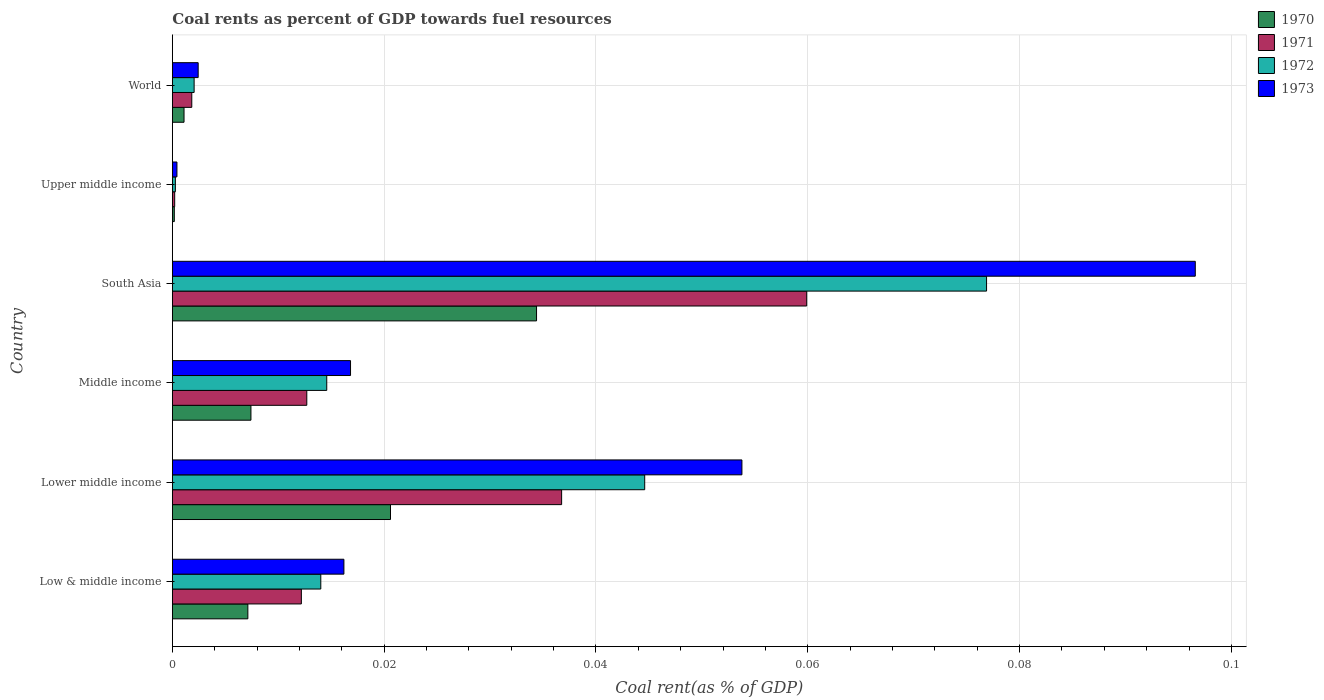Are the number of bars per tick equal to the number of legend labels?
Offer a very short reply. Yes. How many bars are there on the 2nd tick from the top?
Provide a succinct answer. 4. What is the label of the 5th group of bars from the top?
Your response must be concise. Lower middle income. In how many cases, is the number of bars for a given country not equal to the number of legend labels?
Give a very brief answer. 0. What is the coal rent in 1970 in Middle income?
Your answer should be very brief. 0.01. Across all countries, what is the maximum coal rent in 1970?
Provide a short and direct response. 0.03. Across all countries, what is the minimum coal rent in 1971?
Offer a terse response. 0. In which country was the coal rent in 1972 maximum?
Your answer should be very brief. South Asia. In which country was the coal rent in 1970 minimum?
Ensure brevity in your answer.  Upper middle income. What is the total coal rent in 1973 in the graph?
Your response must be concise. 0.19. What is the difference between the coal rent in 1970 in Middle income and that in South Asia?
Give a very brief answer. -0.03. What is the difference between the coal rent in 1970 in Middle income and the coal rent in 1971 in Upper middle income?
Your response must be concise. 0.01. What is the average coal rent in 1971 per country?
Keep it short and to the point. 0.02. What is the difference between the coal rent in 1970 and coal rent in 1972 in World?
Provide a succinct answer. -0. What is the ratio of the coal rent in 1972 in Low & middle income to that in Middle income?
Offer a very short reply. 0.96. Is the coal rent in 1970 in Low & middle income less than that in Lower middle income?
Make the answer very short. Yes. What is the difference between the highest and the second highest coal rent in 1973?
Make the answer very short. 0.04. What is the difference between the highest and the lowest coal rent in 1971?
Offer a very short reply. 0.06. Is it the case that in every country, the sum of the coal rent in 1972 and coal rent in 1971 is greater than the sum of coal rent in 1973 and coal rent in 1970?
Your answer should be compact. No. What does the 1st bar from the top in Low & middle income represents?
Ensure brevity in your answer.  1973. How many bars are there?
Your answer should be very brief. 24. Are all the bars in the graph horizontal?
Offer a very short reply. Yes. What is the difference between two consecutive major ticks on the X-axis?
Ensure brevity in your answer.  0.02. Are the values on the major ticks of X-axis written in scientific E-notation?
Offer a very short reply. No. What is the title of the graph?
Keep it short and to the point. Coal rents as percent of GDP towards fuel resources. What is the label or title of the X-axis?
Your answer should be very brief. Coal rent(as % of GDP). What is the Coal rent(as % of GDP) of 1970 in Low & middle income?
Ensure brevity in your answer.  0.01. What is the Coal rent(as % of GDP) in 1971 in Low & middle income?
Your answer should be compact. 0.01. What is the Coal rent(as % of GDP) in 1972 in Low & middle income?
Keep it short and to the point. 0.01. What is the Coal rent(as % of GDP) of 1973 in Low & middle income?
Make the answer very short. 0.02. What is the Coal rent(as % of GDP) in 1970 in Lower middle income?
Your response must be concise. 0.02. What is the Coal rent(as % of GDP) of 1971 in Lower middle income?
Ensure brevity in your answer.  0.04. What is the Coal rent(as % of GDP) of 1972 in Lower middle income?
Provide a succinct answer. 0.04. What is the Coal rent(as % of GDP) of 1973 in Lower middle income?
Provide a short and direct response. 0.05. What is the Coal rent(as % of GDP) in 1970 in Middle income?
Your answer should be very brief. 0.01. What is the Coal rent(as % of GDP) of 1971 in Middle income?
Give a very brief answer. 0.01. What is the Coal rent(as % of GDP) of 1972 in Middle income?
Offer a very short reply. 0.01. What is the Coal rent(as % of GDP) of 1973 in Middle income?
Keep it short and to the point. 0.02. What is the Coal rent(as % of GDP) in 1970 in South Asia?
Provide a succinct answer. 0.03. What is the Coal rent(as % of GDP) of 1971 in South Asia?
Your answer should be compact. 0.06. What is the Coal rent(as % of GDP) in 1972 in South Asia?
Give a very brief answer. 0.08. What is the Coal rent(as % of GDP) of 1973 in South Asia?
Ensure brevity in your answer.  0.1. What is the Coal rent(as % of GDP) in 1970 in Upper middle income?
Offer a very short reply. 0. What is the Coal rent(as % of GDP) in 1971 in Upper middle income?
Make the answer very short. 0. What is the Coal rent(as % of GDP) of 1972 in Upper middle income?
Offer a terse response. 0. What is the Coal rent(as % of GDP) in 1973 in Upper middle income?
Keep it short and to the point. 0. What is the Coal rent(as % of GDP) in 1970 in World?
Give a very brief answer. 0. What is the Coal rent(as % of GDP) of 1971 in World?
Give a very brief answer. 0. What is the Coal rent(as % of GDP) of 1972 in World?
Offer a very short reply. 0. What is the Coal rent(as % of GDP) in 1973 in World?
Your response must be concise. 0. Across all countries, what is the maximum Coal rent(as % of GDP) of 1970?
Provide a short and direct response. 0.03. Across all countries, what is the maximum Coal rent(as % of GDP) of 1971?
Offer a terse response. 0.06. Across all countries, what is the maximum Coal rent(as % of GDP) in 1972?
Provide a succinct answer. 0.08. Across all countries, what is the maximum Coal rent(as % of GDP) of 1973?
Provide a short and direct response. 0.1. Across all countries, what is the minimum Coal rent(as % of GDP) in 1970?
Provide a short and direct response. 0. Across all countries, what is the minimum Coal rent(as % of GDP) of 1971?
Ensure brevity in your answer.  0. Across all countries, what is the minimum Coal rent(as % of GDP) in 1972?
Keep it short and to the point. 0. Across all countries, what is the minimum Coal rent(as % of GDP) of 1973?
Ensure brevity in your answer.  0. What is the total Coal rent(as % of GDP) in 1970 in the graph?
Your answer should be compact. 0.07. What is the total Coal rent(as % of GDP) in 1971 in the graph?
Provide a short and direct response. 0.12. What is the total Coal rent(as % of GDP) in 1972 in the graph?
Provide a succinct answer. 0.15. What is the total Coal rent(as % of GDP) of 1973 in the graph?
Offer a very short reply. 0.19. What is the difference between the Coal rent(as % of GDP) in 1970 in Low & middle income and that in Lower middle income?
Keep it short and to the point. -0.01. What is the difference between the Coal rent(as % of GDP) in 1971 in Low & middle income and that in Lower middle income?
Your response must be concise. -0.02. What is the difference between the Coal rent(as % of GDP) in 1972 in Low & middle income and that in Lower middle income?
Provide a succinct answer. -0.03. What is the difference between the Coal rent(as % of GDP) of 1973 in Low & middle income and that in Lower middle income?
Your answer should be very brief. -0.04. What is the difference between the Coal rent(as % of GDP) of 1970 in Low & middle income and that in Middle income?
Make the answer very short. -0. What is the difference between the Coal rent(as % of GDP) in 1971 in Low & middle income and that in Middle income?
Provide a short and direct response. -0. What is the difference between the Coal rent(as % of GDP) of 1972 in Low & middle income and that in Middle income?
Make the answer very short. -0. What is the difference between the Coal rent(as % of GDP) of 1973 in Low & middle income and that in Middle income?
Ensure brevity in your answer.  -0. What is the difference between the Coal rent(as % of GDP) of 1970 in Low & middle income and that in South Asia?
Your answer should be compact. -0.03. What is the difference between the Coal rent(as % of GDP) in 1971 in Low & middle income and that in South Asia?
Your answer should be very brief. -0.05. What is the difference between the Coal rent(as % of GDP) of 1972 in Low & middle income and that in South Asia?
Keep it short and to the point. -0.06. What is the difference between the Coal rent(as % of GDP) in 1973 in Low & middle income and that in South Asia?
Make the answer very short. -0.08. What is the difference between the Coal rent(as % of GDP) in 1970 in Low & middle income and that in Upper middle income?
Make the answer very short. 0.01. What is the difference between the Coal rent(as % of GDP) of 1971 in Low & middle income and that in Upper middle income?
Make the answer very short. 0.01. What is the difference between the Coal rent(as % of GDP) of 1972 in Low & middle income and that in Upper middle income?
Provide a succinct answer. 0.01. What is the difference between the Coal rent(as % of GDP) of 1973 in Low & middle income and that in Upper middle income?
Offer a very short reply. 0.02. What is the difference between the Coal rent(as % of GDP) in 1970 in Low & middle income and that in World?
Your answer should be very brief. 0.01. What is the difference between the Coal rent(as % of GDP) in 1971 in Low & middle income and that in World?
Provide a succinct answer. 0.01. What is the difference between the Coal rent(as % of GDP) of 1972 in Low & middle income and that in World?
Keep it short and to the point. 0.01. What is the difference between the Coal rent(as % of GDP) of 1973 in Low & middle income and that in World?
Give a very brief answer. 0.01. What is the difference between the Coal rent(as % of GDP) of 1970 in Lower middle income and that in Middle income?
Your answer should be compact. 0.01. What is the difference between the Coal rent(as % of GDP) of 1971 in Lower middle income and that in Middle income?
Offer a terse response. 0.02. What is the difference between the Coal rent(as % of GDP) in 1972 in Lower middle income and that in Middle income?
Offer a very short reply. 0.03. What is the difference between the Coal rent(as % of GDP) of 1973 in Lower middle income and that in Middle income?
Provide a short and direct response. 0.04. What is the difference between the Coal rent(as % of GDP) in 1970 in Lower middle income and that in South Asia?
Provide a succinct answer. -0.01. What is the difference between the Coal rent(as % of GDP) of 1971 in Lower middle income and that in South Asia?
Offer a very short reply. -0.02. What is the difference between the Coal rent(as % of GDP) of 1972 in Lower middle income and that in South Asia?
Your response must be concise. -0.03. What is the difference between the Coal rent(as % of GDP) in 1973 in Lower middle income and that in South Asia?
Your answer should be compact. -0.04. What is the difference between the Coal rent(as % of GDP) in 1970 in Lower middle income and that in Upper middle income?
Keep it short and to the point. 0.02. What is the difference between the Coal rent(as % of GDP) in 1971 in Lower middle income and that in Upper middle income?
Keep it short and to the point. 0.04. What is the difference between the Coal rent(as % of GDP) in 1972 in Lower middle income and that in Upper middle income?
Offer a very short reply. 0.04. What is the difference between the Coal rent(as % of GDP) in 1973 in Lower middle income and that in Upper middle income?
Provide a short and direct response. 0.05. What is the difference between the Coal rent(as % of GDP) in 1970 in Lower middle income and that in World?
Give a very brief answer. 0.02. What is the difference between the Coal rent(as % of GDP) in 1971 in Lower middle income and that in World?
Give a very brief answer. 0.03. What is the difference between the Coal rent(as % of GDP) in 1972 in Lower middle income and that in World?
Offer a very short reply. 0.04. What is the difference between the Coal rent(as % of GDP) of 1973 in Lower middle income and that in World?
Your response must be concise. 0.05. What is the difference between the Coal rent(as % of GDP) in 1970 in Middle income and that in South Asia?
Make the answer very short. -0.03. What is the difference between the Coal rent(as % of GDP) of 1971 in Middle income and that in South Asia?
Offer a very short reply. -0.05. What is the difference between the Coal rent(as % of GDP) of 1972 in Middle income and that in South Asia?
Keep it short and to the point. -0.06. What is the difference between the Coal rent(as % of GDP) in 1973 in Middle income and that in South Asia?
Offer a very short reply. -0.08. What is the difference between the Coal rent(as % of GDP) of 1970 in Middle income and that in Upper middle income?
Your answer should be compact. 0.01. What is the difference between the Coal rent(as % of GDP) in 1971 in Middle income and that in Upper middle income?
Ensure brevity in your answer.  0.01. What is the difference between the Coal rent(as % of GDP) in 1972 in Middle income and that in Upper middle income?
Offer a terse response. 0.01. What is the difference between the Coal rent(as % of GDP) of 1973 in Middle income and that in Upper middle income?
Keep it short and to the point. 0.02. What is the difference between the Coal rent(as % of GDP) of 1970 in Middle income and that in World?
Keep it short and to the point. 0.01. What is the difference between the Coal rent(as % of GDP) in 1971 in Middle income and that in World?
Offer a terse response. 0.01. What is the difference between the Coal rent(as % of GDP) in 1972 in Middle income and that in World?
Provide a succinct answer. 0.01. What is the difference between the Coal rent(as % of GDP) in 1973 in Middle income and that in World?
Offer a terse response. 0.01. What is the difference between the Coal rent(as % of GDP) of 1970 in South Asia and that in Upper middle income?
Your response must be concise. 0.03. What is the difference between the Coal rent(as % of GDP) of 1971 in South Asia and that in Upper middle income?
Your response must be concise. 0.06. What is the difference between the Coal rent(as % of GDP) in 1972 in South Asia and that in Upper middle income?
Your response must be concise. 0.08. What is the difference between the Coal rent(as % of GDP) of 1973 in South Asia and that in Upper middle income?
Provide a short and direct response. 0.1. What is the difference between the Coal rent(as % of GDP) of 1970 in South Asia and that in World?
Ensure brevity in your answer.  0.03. What is the difference between the Coal rent(as % of GDP) of 1971 in South Asia and that in World?
Ensure brevity in your answer.  0.06. What is the difference between the Coal rent(as % of GDP) in 1972 in South Asia and that in World?
Your answer should be very brief. 0.07. What is the difference between the Coal rent(as % of GDP) of 1973 in South Asia and that in World?
Provide a succinct answer. 0.09. What is the difference between the Coal rent(as % of GDP) of 1970 in Upper middle income and that in World?
Offer a terse response. -0. What is the difference between the Coal rent(as % of GDP) in 1971 in Upper middle income and that in World?
Provide a succinct answer. -0. What is the difference between the Coal rent(as % of GDP) of 1972 in Upper middle income and that in World?
Your answer should be very brief. -0. What is the difference between the Coal rent(as % of GDP) of 1973 in Upper middle income and that in World?
Provide a short and direct response. -0. What is the difference between the Coal rent(as % of GDP) of 1970 in Low & middle income and the Coal rent(as % of GDP) of 1971 in Lower middle income?
Provide a short and direct response. -0.03. What is the difference between the Coal rent(as % of GDP) of 1970 in Low & middle income and the Coal rent(as % of GDP) of 1972 in Lower middle income?
Offer a terse response. -0.04. What is the difference between the Coal rent(as % of GDP) of 1970 in Low & middle income and the Coal rent(as % of GDP) of 1973 in Lower middle income?
Keep it short and to the point. -0.05. What is the difference between the Coal rent(as % of GDP) of 1971 in Low & middle income and the Coal rent(as % of GDP) of 1972 in Lower middle income?
Offer a terse response. -0.03. What is the difference between the Coal rent(as % of GDP) of 1971 in Low & middle income and the Coal rent(as % of GDP) of 1973 in Lower middle income?
Your response must be concise. -0.04. What is the difference between the Coal rent(as % of GDP) of 1972 in Low & middle income and the Coal rent(as % of GDP) of 1973 in Lower middle income?
Your answer should be very brief. -0.04. What is the difference between the Coal rent(as % of GDP) of 1970 in Low & middle income and the Coal rent(as % of GDP) of 1971 in Middle income?
Provide a succinct answer. -0.01. What is the difference between the Coal rent(as % of GDP) in 1970 in Low & middle income and the Coal rent(as % of GDP) in 1972 in Middle income?
Offer a terse response. -0.01. What is the difference between the Coal rent(as % of GDP) in 1970 in Low & middle income and the Coal rent(as % of GDP) in 1973 in Middle income?
Give a very brief answer. -0.01. What is the difference between the Coal rent(as % of GDP) in 1971 in Low & middle income and the Coal rent(as % of GDP) in 1972 in Middle income?
Make the answer very short. -0. What is the difference between the Coal rent(as % of GDP) in 1971 in Low & middle income and the Coal rent(as % of GDP) in 1973 in Middle income?
Offer a very short reply. -0. What is the difference between the Coal rent(as % of GDP) of 1972 in Low & middle income and the Coal rent(as % of GDP) of 1973 in Middle income?
Your answer should be compact. -0. What is the difference between the Coal rent(as % of GDP) of 1970 in Low & middle income and the Coal rent(as % of GDP) of 1971 in South Asia?
Ensure brevity in your answer.  -0.05. What is the difference between the Coal rent(as % of GDP) of 1970 in Low & middle income and the Coal rent(as % of GDP) of 1972 in South Asia?
Give a very brief answer. -0.07. What is the difference between the Coal rent(as % of GDP) of 1970 in Low & middle income and the Coal rent(as % of GDP) of 1973 in South Asia?
Ensure brevity in your answer.  -0.09. What is the difference between the Coal rent(as % of GDP) of 1971 in Low & middle income and the Coal rent(as % of GDP) of 1972 in South Asia?
Provide a succinct answer. -0.06. What is the difference between the Coal rent(as % of GDP) of 1971 in Low & middle income and the Coal rent(as % of GDP) of 1973 in South Asia?
Offer a very short reply. -0.08. What is the difference between the Coal rent(as % of GDP) in 1972 in Low & middle income and the Coal rent(as % of GDP) in 1973 in South Asia?
Keep it short and to the point. -0.08. What is the difference between the Coal rent(as % of GDP) of 1970 in Low & middle income and the Coal rent(as % of GDP) of 1971 in Upper middle income?
Ensure brevity in your answer.  0.01. What is the difference between the Coal rent(as % of GDP) of 1970 in Low & middle income and the Coal rent(as % of GDP) of 1972 in Upper middle income?
Your answer should be compact. 0.01. What is the difference between the Coal rent(as % of GDP) in 1970 in Low & middle income and the Coal rent(as % of GDP) in 1973 in Upper middle income?
Make the answer very short. 0.01. What is the difference between the Coal rent(as % of GDP) in 1971 in Low & middle income and the Coal rent(as % of GDP) in 1972 in Upper middle income?
Give a very brief answer. 0.01. What is the difference between the Coal rent(as % of GDP) in 1971 in Low & middle income and the Coal rent(as % of GDP) in 1973 in Upper middle income?
Offer a very short reply. 0.01. What is the difference between the Coal rent(as % of GDP) of 1972 in Low & middle income and the Coal rent(as % of GDP) of 1973 in Upper middle income?
Your answer should be very brief. 0.01. What is the difference between the Coal rent(as % of GDP) in 1970 in Low & middle income and the Coal rent(as % of GDP) in 1971 in World?
Keep it short and to the point. 0.01. What is the difference between the Coal rent(as % of GDP) of 1970 in Low & middle income and the Coal rent(as % of GDP) of 1972 in World?
Make the answer very short. 0.01. What is the difference between the Coal rent(as % of GDP) in 1970 in Low & middle income and the Coal rent(as % of GDP) in 1973 in World?
Make the answer very short. 0. What is the difference between the Coal rent(as % of GDP) of 1971 in Low & middle income and the Coal rent(as % of GDP) of 1972 in World?
Provide a short and direct response. 0.01. What is the difference between the Coal rent(as % of GDP) of 1971 in Low & middle income and the Coal rent(as % of GDP) of 1973 in World?
Your response must be concise. 0.01. What is the difference between the Coal rent(as % of GDP) of 1972 in Low & middle income and the Coal rent(as % of GDP) of 1973 in World?
Keep it short and to the point. 0.01. What is the difference between the Coal rent(as % of GDP) of 1970 in Lower middle income and the Coal rent(as % of GDP) of 1971 in Middle income?
Your answer should be very brief. 0.01. What is the difference between the Coal rent(as % of GDP) in 1970 in Lower middle income and the Coal rent(as % of GDP) in 1972 in Middle income?
Your answer should be very brief. 0.01. What is the difference between the Coal rent(as % of GDP) in 1970 in Lower middle income and the Coal rent(as % of GDP) in 1973 in Middle income?
Give a very brief answer. 0. What is the difference between the Coal rent(as % of GDP) in 1971 in Lower middle income and the Coal rent(as % of GDP) in 1972 in Middle income?
Offer a very short reply. 0.02. What is the difference between the Coal rent(as % of GDP) in 1971 in Lower middle income and the Coal rent(as % of GDP) in 1973 in Middle income?
Your response must be concise. 0.02. What is the difference between the Coal rent(as % of GDP) of 1972 in Lower middle income and the Coal rent(as % of GDP) of 1973 in Middle income?
Offer a very short reply. 0.03. What is the difference between the Coal rent(as % of GDP) in 1970 in Lower middle income and the Coal rent(as % of GDP) in 1971 in South Asia?
Your answer should be compact. -0.04. What is the difference between the Coal rent(as % of GDP) in 1970 in Lower middle income and the Coal rent(as % of GDP) in 1972 in South Asia?
Provide a succinct answer. -0.06. What is the difference between the Coal rent(as % of GDP) of 1970 in Lower middle income and the Coal rent(as % of GDP) of 1973 in South Asia?
Your answer should be very brief. -0.08. What is the difference between the Coal rent(as % of GDP) in 1971 in Lower middle income and the Coal rent(as % of GDP) in 1972 in South Asia?
Keep it short and to the point. -0.04. What is the difference between the Coal rent(as % of GDP) in 1971 in Lower middle income and the Coal rent(as % of GDP) in 1973 in South Asia?
Your answer should be very brief. -0.06. What is the difference between the Coal rent(as % of GDP) of 1972 in Lower middle income and the Coal rent(as % of GDP) of 1973 in South Asia?
Your response must be concise. -0.05. What is the difference between the Coal rent(as % of GDP) of 1970 in Lower middle income and the Coal rent(as % of GDP) of 1971 in Upper middle income?
Your answer should be compact. 0.02. What is the difference between the Coal rent(as % of GDP) in 1970 in Lower middle income and the Coal rent(as % of GDP) in 1972 in Upper middle income?
Your answer should be very brief. 0.02. What is the difference between the Coal rent(as % of GDP) of 1970 in Lower middle income and the Coal rent(as % of GDP) of 1973 in Upper middle income?
Provide a short and direct response. 0.02. What is the difference between the Coal rent(as % of GDP) in 1971 in Lower middle income and the Coal rent(as % of GDP) in 1972 in Upper middle income?
Offer a very short reply. 0.04. What is the difference between the Coal rent(as % of GDP) in 1971 in Lower middle income and the Coal rent(as % of GDP) in 1973 in Upper middle income?
Offer a very short reply. 0.04. What is the difference between the Coal rent(as % of GDP) in 1972 in Lower middle income and the Coal rent(as % of GDP) in 1973 in Upper middle income?
Your answer should be very brief. 0.04. What is the difference between the Coal rent(as % of GDP) of 1970 in Lower middle income and the Coal rent(as % of GDP) of 1971 in World?
Offer a very short reply. 0.02. What is the difference between the Coal rent(as % of GDP) in 1970 in Lower middle income and the Coal rent(as % of GDP) in 1972 in World?
Provide a succinct answer. 0.02. What is the difference between the Coal rent(as % of GDP) in 1970 in Lower middle income and the Coal rent(as % of GDP) in 1973 in World?
Your response must be concise. 0.02. What is the difference between the Coal rent(as % of GDP) in 1971 in Lower middle income and the Coal rent(as % of GDP) in 1972 in World?
Your answer should be compact. 0.03. What is the difference between the Coal rent(as % of GDP) of 1971 in Lower middle income and the Coal rent(as % of GDP) of 1973 in World?
Offer a very short reply. 0.03. What is the difference between the Coal rent(as % of GDP) of 1972 in Lower middle income and the Coal rent(as % of GDP) of 1973 in World?
Provide a succinct answer. 0.04. What is the difference between the Coal rent(as % of GDP) of 1970 in Middle income and the Coal rent(as % of GDP) of 1971 in South Asia?
Make the answer very short. -0.05. What is the difference between the Coal rent(as % of GDP) of 1970 in Middle income and the Coal rent(as % of GDP) of 1972 in South Asia?
Ensure brevity in your answer.  -0.07. What is the difference between the Coal rent(as % of GDP) of 1970 in Middle income and the Coal rent(as % of GDP) of 1973 in South Asia?
Keep it short and to the point. -0.09. What is the difference between the Coal rent(as % of GDP) in 1971 in Middle income and the Coal rent(as % of GDP) in 1972 in South Asia?
Give a very brief answer. -0.06. What is the difference between the Coal rent(as % of GDP) of 1971 in Middle income and the Coal rent(as % of GDP) of 1973 in South Asia?
Your answer should be compact. -0.08. What is the difference between the Coal rent(as % of GDP) in 1972 in Middle income and the Coal rent(as % of GDP) in 1973 in South Asia?
Give a very brief answer. -0.08. What is the difference between the Coal rent(as % of GDP) in 1970 in Middle income and the Coal rent(as % of GDP) in 1971 in Upper middle income?
Offer a terse response. 0.01. What is the difference between the Coal rent(as % of GDP) of 1970 in Middle income and the Coal rent(as % of GDP) of 1972 in Upper middle income?
Offer a very short reply. 0.01. What is the difference between the Coal rent(as % of GDP) in 1970 in Middle income and the Coal rent(as % of GDP) in 1973 in Upper middle income?
Your answer should be very brief. 0.01. What is the difference between the Coal rent(as % of GDP) in 1971 in Middle income and the Coal rent(as % of GDP) in 1972 in Upper middle income?
Your answer should be very brief. 0.01. What is the difference between the Coal rent(as % of GDP) of 1971 in Middle income and the Coal rent(as % of GDP) of 1973 in Upper middle income?
Ensure brevity in your answer.  0.01. What is the difference between the Coal rent(as % of GDP) of 1972 in Middle income and the Coal rent(as % of GDP) of 1973 in Upper middle income?
Your answer should be very brief. 0.01. What is the difference between the Coal rent(as % of GDP) in 1970 in Middle income and the Coal rent(as % of GDP) in 1971 in World?
Provide a short and direct response. 0.01. What is the difference between the Coal rent(as % of GDP) in 1970 in Middle income and the Coal rent(as % of GDP) in 1972 in World?
Your response must be concise. 0.01. What is the difference between the Coal rent(as % of GDP) of 1970 in Middle income and the Coal rent(as % of GDP) of 1973 in World?
Your response must be concise. 0.01. What is the difference between the Coal rent(as % of GDP) of 1971 in Middle income and the Coal rent(as % of GDP) of 1972 in World?
Your response must be concise. 0.01. What is the difference between the Coal rent(as % of GDP) of 1971 in Middle income and the Coal rent(as % of GDP) of 1973 in World?
Offer a terse response. 0.01. What is the difference between the Coal rent(as % of GDP) of 1972 in Middle income and the Coal rent(as % of GDP) of 1973 in World?
Keep it short and to the point. 0.01. What is the difference between the Coal rent(as % of GDP) in 1970 in South Asia and the Coal rent(as % of GDP) in 1971 in Upper middle income?
Offer a terse response. 0.03. What is the difference between the Coal rent(as % of GDP) of 1970 in South Asia and the Coal rent(as % of GDP) of 1972 in Upper middle income?
Make the answer very short. 0.03. What is the difference between the Coal rent(as % of GDP) in 1970 in South Asia and the Coal rent(as % of GDP) in 1973 in Upper middle income?
Offer a very short reply. 0.03. What is the difference between the Coal rent(as % of GDP) in 1971 in South Asia and the Coal rent(as % of GDP) in 1972 in Upper middle income?
Make the answer very short. 0.06. What is the difference between the Coal rent(as % of GDP) in 1971 in South Asia and the Coal rent(as % of GDP) in 1973 in Upper middle income?
Provide a short and direct response. 0.06. What is the difference between the Coal rent(as % of GDP) of 1972 in South Asia and the Coal rent(as % of GDP) of 1973 in Upper middle income?
Offer a very short reply. 0.08. What is the difference between the Coal rent(as % of GDP) of 1970 in South Asia and the Coal rent(as % of GDP) of 1971 in World?
Make the answer very short. 0.03. What is the difference between the Coal rent(as % of GDP) in 1970 in South Asia and the Coal rent(as % of GDP) in 1972 in World?
Make the answer very short. 0.03. What is the difference between the Coal rent(as % of GDP) of 1970 in South Asia and the Coal rent(as % of GDP) of 1973 in World?
Your response must be concise. 0.03. What is the difference between the Coal rent(as % of GDP) of 1971 in South Asia and the Coal rent(as % of GDP) of 1972 in World?
Provide a succinct answer. 0.06. What is the difference between the Coal rent(as % of GDP) of 1971 in South Asia and the Coal rent(as % of GDP) of 1973 in World?
Offer a terse response. 0.06. What is the difference between the Coal rent(as % of GDP) of 1972 in South Asia and the Coal rent(as % of GDP) of 1973 in World?
Make the answer very short. 0.07. What is the difference between the Coal rent(as % of GDP) in 1970 in Upper middle income and the Coal rent(as % of GDP) in 1971 in World?
Offer a terse response. -0. What is the difference between the Coal rent(as % of GDP) of 1970 in Upper middle income and the Coal rent(as % of GDP) of 1972 in World?
Offer a terse response. -0. What is the difference between the Coal rent(as % of GDP) in 1970 in Upper middle income and the Coal rent(as % of GDP) in 1973 in World?
Keep it short and to the point. -0. What is the difference between the Coal rent(as % of GDP) in 1971 in Upper middle income and the Coal rent(as % of GDP) in 1972 in World?
Ensure brevity in your answer.  -0. What is the difference between the Coal rent(as % of GDP) in 1971 in Upper middle income and the Coal rent(as % of GDP) in 1973 in World?
Provide a short and direct response. -0. What is the difference between the Coal rent(as % of GDP) of 1972 in Upper middle income and the Coal rent(as % of GDP) of 1973 in World?
Give a very brief answer. -0. What is the average Coal rent(as % of GDP) of 1970 per country?
Offer a very short reply. 0.01. What is the average Coal rent(as % of GDP) in 1971 per country?
Make the answer very short. 0.02. What is the average Coal rent(as % of GDP) in 1972 per country?
Your response must be concise. 0.03. What is the average Coal rent(as % of GDP) of 1973 per country?
Your response must be concise. 0.03. What is the difference between the Coal rent(as % of GDP) in 1970 and Coal rent(as % of GDP) in 1971 in Low & middle income?
Provide a short and direct response. -0.01. What is the difference between the Coal rent(as % of GDP) of 1970 and Coal rent(as % of GDP) of 1972 in Low & middle income?
Offer a terse response. -0.01. What is the difference between the Coal rent(as % of GDP) in 1970 and Coal rent(as % of GDP) in 1973 in Low & middle income?
Offer a terse response. -0.01. What is the difference between the Coal rent(as % of GDP) in 1971 and Coal rent(as % of GDP) in 1972 in Low & middle income?
Make the answer very short. -0. What is the difference between the Coal rent(as % of GDP) in 1971 and Coal rent(as % of GDP) in 1973 in Low & middle income?
Your answer should be compact. -0. What is the difference between the Coal rent(as % of GDP) of 1972 and Coal rent(as % of GDP) of 1973 in Low & middle income?
Offer a terse response. -0. What is the difference between the Coal rent(as % of GDP) of 1970 and Coal rent(as % of GDP) of 1971 in Lower middle income?
Offer a very short reply. -0.02. What is the difference between the Coal rent(as % of GDP) of 1970 and Coal rent(as % of GDP) of 1972 in Lower middle income?
Your response must be concise. -0.02. What is the difference between the Coal rent(as % of GDP) in 1970 and Coal rent(as % of GDP) in 1973 in Lower middle income?
Your response must be concise. -0.03. What is the difference between the Coal rent(as % of GDP) of 1971 and Coal rent(as % of GDP) of 1972 in Lower middle income?
Offer a very short reply. -0.01. What is the difference between the Coal rent(as % of GDP) in 1971 and Coal rent(as % of GDP) in 1973 in Lower middle income?
Your answer should be very brief. -0.02. What is the difference between the Coal rent(as % of GDP) in 1972 and Coal rent(as % of GDP) in 1973 in Lower middle income?
Provide a short and direct response. -0.01. What is the difference between the Coal rent(as % of GDP) in 1970 and Coal rent(as % of GDP) in 1971 in Middle income?
Provide a succinct answer. -0.01. What is the difference between the Coal rent(as % of GDP) of 1970 and Coal rent(as % of GDP) of 1972 in Middle income?
Provide a succinct answer. -0.01. What is the difference between the Coal rent(as % of GDP) in 1970 and Coal rent(as % of GDP) in 1973 in Middle income?
Make the answer very short. -0.01. What is the difference between the Coal rent(as % of GDP) in 1971 and Coal rent(as % of GDP) in 1972 in Middle income?
Ensure brevity in your answer.  -0. What is the difference between the Coal rent(as % of GDP) in 1971 and Coal rent(as % of GDP) in 1973 in Middle income?
Give a very brief answer. -0. What is the difference between the Coal rent(as % of GDP) of 1972 and Coal rent(as % of GDP) of 1973 in Middle income?
Make the answer very short. -0. What is the difference between the Coal rent(as % of GDP) in 1970 and Coal rent(as % of GDP) in 1971 in South Asia?
Your response must be concise. -0.03. What is the difference between the Coal rent(as % of GDP) of 1970 and Coal rent(as % of GDP) of 1972 in South Asia?
Provide a short and direct response. -0.04. What is the difference between the Coal rent(as % of GDP) of 1970 and Coal rent(as % of GDP) of 1973 in South Asia?
Your answer should be very brief. -0.06. What is the difference between the Coal rent(as % of GDP) in 1971 and Coal rent(as % of GDP) in 1972 in South Asia?
Offer a terse response. -0.02. What is the difference between the Coal rent(as % of GDP) of 1971 and Coal rent(as % of GDP) of 1973 in South Asia?
Your response must be concise. -0.04. What is the difference between the Coal rent(as % of GDP) in 1972 and Coal rent(as % of GDP) in 1973 in South Asia?
Your response must be concise. -0.02. What is the difference between the Coal rent(as % of GDP) in 1970 and Coal rent(as % of GDP) in 1971 in Upper middle income?
Keep it short and to the point. -0. What is the difference between the Coal rent(as % of GDP) in 1970 and Coal rent(as % of GDP) in 1972 in Upper middle income?
Your answer should be compact. -0. What is the difference between the Coal rent(as % of GDP) in 1970 and Coal rent(as % of GDP) in 1973 in Upper middle income?
Offer a very short reply. -0. What is the difference between the Coal rent(as % of GDP) in 1971 and Coal rent(as % of GDP) in 1972 in Upper middle income?
Provide a short and direct response. -0. What is the difference between the Coal rent(as % of GDP) of 1971 and Coal rent(as % of GDP) of 1973 in Upper middle income?
Your answer should be very brief. -0. What is the difference between the Coal rent(as % of GDP) in 1972 and Coal rent(as % of GDP) in 1973 in Upper middle income?
Your answer should be compact. -0. What is the difference between the Coal rent(as % of GDP) in 1970 and Coal rent(as % of GDP) in 1971 in World?
Your answer should be very brief. -0. What is the difference between the Coal rent(as % of GDP) in 1970 and Coal rent(as % of GDP) in 1972 in World?
Ensure brevity in your answer.  -0. What is the difference between the Coal rent(as % of GDP) of 1970 and Coal rent(as % of GDP) of 1973 in World?
Give a very brief answer. -0. What is the difference between the Coal rent(as % of GDP) in 1971 and Coal rent(as % of GDP) in 1972 in World?
Ensure brevity in your answer.  -0. What is the difference between the Coal rent(as % of GDP) of 1971 and Coal rent(as % of GDP) of 1973 in World?
Offer a terse response. -0. What is the difference between the Coal rent(as % of GDP) of 1972 and Coal rent(as % of GDP) of 1973 in World?
Ensure brevity in your answer.  -0. What is the ratio of the Coal rent(as % of GDP) of 1970 in Low & middle income to that in Lower middle income?
Make the answer very short. 0.35. What is the ratio of the Coal rent(as % of GDP) of 1971 in Low & middle income to that in Lower middle income?
Offer a terse response. 0.33. What is the ratio of the Coal rent(as % of GDP) of 1972 in Low & middle income to that in Lower middle income?
Offer a very short reply. 0.31. What is the ratio of the Coal rent(as % of GDP) of 1973 in Low & middle income to that in Lower middle income?
Make the answer very short. 0.3. What is the ratio of the Coal rent(as % of GDP) of 1970 in Low & middle income to that in Middle income?
Your answer should be very brief. 0.96. What is the ratio of the Coal rent(as % of GDP) in 1971 in Low & middle income to that in Middle income?
Make the answer very short. 0.96. What is the ratio of the Coal rent(as % of GDP) of 1972 in Low & middle income to that in Middle income?
Your answer should be compact. 0.96. What is the ratio of the Coal rent(as % of GDP) in 1973 in Low & middle income to that in Middle income?
Keep it short and to the point. 0.96. What is the ratio of the Coal rent(as % of GDP) of 1970 in Low & middle income to that in South Asia?
Offer a very short reply. 0.21. What is the ratio of the Coal rent(as % of GDP) in 1971 in Low & middle income to that in South Asia?
Your response must be concise. 0.2. What is the ratio of the Coal rent(as % of GDP) in 1972 in Low & middle income to that in South Asia?
Provide a succinct answer. 0.18. What is the ratio of the Coal rent(as % of GDP) of 1973 in Low & middle income to that in South Asia?
Offer a very short reply. 0.17. What is the ratio of the Coal rent(as % of GDP) in 1970 in Low & middle income to that in Upper middle income?
Make the answer very short. 38.77. What is the ratio of the Coal rent(as % of GDP) in 1971 in Low & middle income to that in Upper middle income?
Provide a succinct answer. 55.66. What is the ratio of the Coal rent(as % of GDP) in 1972 in Low & middle income to that in Upper middle income?
Your answer should be very brief. 49.28. What is the ratio of the Coal rent(as % of GDP) of 1973 in Low & middle income to that in Upper middle income?
Give a very brief answer. 37.59. What is the ratio of the Coal rent(as % of GDP) of 1970 in Low & middle income to that in World?
Provide a short and direct response. 6.48. What is the ratio of the Coal rent(as % of GDP) in 1971 in Low & middle income to that in World?
Your answer should be very brief. 6.65. What is the ratio of the Coal rent(as % of GDP) in 1972 in Low & middle income to that in World?
Give a very brief answer. 6.82. What is the ratio of the Coal rent(as % of GDP) in 1973 in Low & middle income to that in World?
Provide a succinct answer. 6.65. What is the ratio of the Coal rent(as % of GDP) in 1970 in Lower middle income to that in Middle income?
Ensure brevity in your answer.  2.78. What is the ratio of the Coal rent(as % of GDP) in 1971 in Lower middle income to that in Middle income?
Offer a terse response. 2.9. What is the ratio of the Coal rent(as % of GDP) of 1972 in Lower middle income to that in Middle income?
Provide a short and direct response. 3.06. What is the ratio of the Coal rent(as % of GDP) in 1973 in Lower middle income to that in Middle income?
Your answer should be very brief. 3.2. What is the ratio of the Coal rent(as % of GDP) in 1970 in Lower middle income to that in South Asia?
Make the answer very short. 0.6. What is the ratio of the Coal rent(as % of GDP) in 1971 in Lower middle income to that in South Asia?
Offer a terse response. 0.61. What is the ratio of the Coal rent(as % of GDP) of 1972 in Lower middle income to that in South Asia?
Make the answer very short. 0.58. What is the ratio of the Coal rent(as % of GDP) in 1973 in Lower middle income to that in South Asia?
Your answer should be very brief. 0.56. What is the ratio of the Coal rent(as % of GDP) in 1970 in Lower middle income to that in Upper middle income?
Offer a terse response. 112.03. What is the ratio of the Coal rent(as % of GDP) in 1971 in Lower middle income to that in Upper middle income?
Keep it short and to the point. 167.98. What is the ratio of the Coal rent(as % of GDP) of 1972 in Lower middle income to that in Upper middle income?
Offer a very short reply. 156.82. What is the ratio of the Coal rent(as % of GDP) of 1973 in Lower middle income to that in Upper middle income?
Offer a terse response. 124.82. What is the ratio of the Coal rent(as % of GDP) of 1970 in Lower middle income to that in World?
Provide a short and direct response. 18.71. What is the ratio of the Coal rent(as % of GDP) of 1971 in Lower middle income to that in World?
Offer a very short reply. 20.06. What is the ratio of the Coal rent(as % of GDP) in 1972 in Lower middle income to that in World?
Provide a succinct answer. 21.7. What is the ratio of the Coal rent(as % of GDP) of 1973 in Lower middle income to that in World?
Provide a short and direct response. 22.07. What is the ratio of the Coal rent(as % of GDP) in 1970 in Middle income to that in South Asia?
Your answer should be compact. 0.22. What is the ratio of the Coal rent(as % of GDP) of 1971 in Middle income to that in South Asia?
Provide a succinct answer. 0.21. What is the ratio of the Coal rent(as % of GDP) of 1972 in Middle income to that in South Asia?
Provide a short and direct response. 0.19. What is the ratio of the Coal rent(as % of GDP) of 1973 in Middle income to that in South Asia?
Keep it short and to the point. 0.17. What is the ratio of the Coal rent(as % of GDP) in 1970 in Middle income to that in Upper middle income?
Your answer should be very brief. 40.36. What is the ratio of the Coal rent(as % of GDP) in 1971 in Middle income to that in Upper middle income?
Your answer should be very brief. 58.01. What is the ratio of the Coal rent(as % of GDP) in 1972 in Middle income to that in Upper middle income?
Make the answer very short. 51.25. What is the ratio of the Coal rent(as % of GDP) of 1973 in Middle income to that in Upper middle income?
Your response must be concise. 39.04. What is the ratio of the Coal rent(as % of GDP) of 1970 in Middle income to that in World?
Your answer should be very brief. 6.74. What is the ratio of the Coal rent(as % of GDP) in 1971 in Middle income to that in World?
Provide a short and direct response. 6.93. What is the ratio of the Coal rent(as % of GDP) in 1972 in Middle income to that in World?
Your answer should be compact. 7.09. What is the ratio of the Coal rent(as % of GDP) of 1973 in Middle income to that in World?
Provide a short and direct response. 6.91. What is the ratio of the Coal rent(as % of GDP) of 1970 in South Asia to that in Upper middle income?
Provide a short and direct response. 187.05. What is the ratio of the Coal rent(as % of GDP) of 1971 in South Asia to that in Upper middle income?
Offer a very short reply. 273.74. What is the ratio of the Coal rent(as % of GDP) in 1972 in South Asia to that in Upper middle income?
Your answer should be compact. 270.32. What is the ratio of the Coal rent(as % of GDP) in 1973 in South Asia to that in Upper middle income?
Offer a very short reply. 224.18. What is the ratio of the Coal rent(as % of GDP) in 1970 in South Asia to that in World?
Make the answer very short. 31.24. What is the ratio of the Coal rent(as % of GDP) of 1971 in South Asia to that in World?
Give a very brief answer. 32.69. What is the ratio of the Coal rent(as % of GDP) in 1972 in South Asia to that in World?
Make the answer very short. 37.41. What is the ratio of the Coal rent(as % of GDP) in 1973 in South Asia to that in World?
Provide a succinct answer. 39.65. What is the ratio of the Coal rent(as % of GDP) in 1970 in Upper middle income to that in World?
Make the answer very short. 0.17. What is the ratio of the Coal rent(as % of GDP) of 1971 in Upper middle income to that in World?
Provide a short and direct response. 0.12. What is the ratio of the Coal rent(as % of GDP) of 1972 in Upper middle income to that in World?
Provide a succinct answer. 0.14. What is the ratio of the Coal rent(as % of GDP) of 1973 in Upper middle income to that in World?
Your response must be concise. 0.18. What is the difference between the highest and the second highest Coal rent(as % of GDP) of 1970?
Your answer should be very brief. 0.01. What is the difference between the highest and the second highest Coal rent(as % of GDP) in 1971?
Offer a very short reply. 0.02. What is the difference between the highest and the second highest Coal rent(as % of GDP) of 1972?
Your answer should be compact. 0.03. What is the difference between the highest and the second highest Coal rent(as % of GDP) of 1973?
Give a very brief answer. 0.04. What is the difference between the highest and the lowest Coal rent(as % of GDP) in 1970?
Provide a short and direct response. 0.03. What is the difference between the highest and the lowest Coal rent(as % of GDP) in 1971?
Provide a short and direct response. 0.06. What is the difference between the highest and the lowest Coal rent(as % of GDP) in 1972?
Your answer should be compact. 0.08. What is the difference between the highest and the lowest Coal rent(as % of GDP) of 1973?
Offer a terse response. 0.1. 